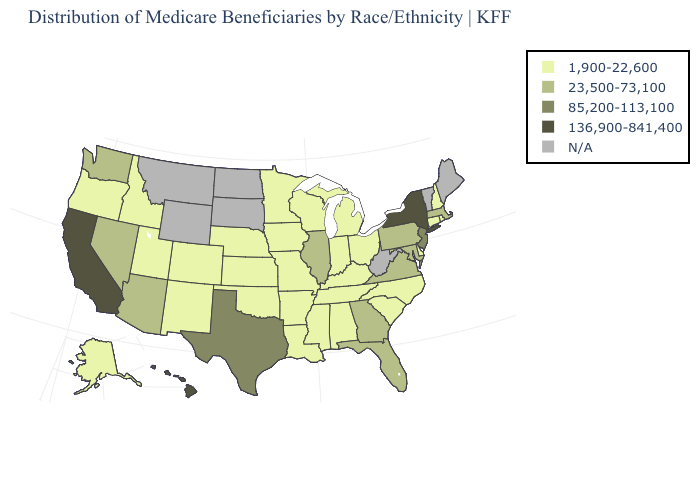Name the states that have a value in the range 23,500-73,100?
Keep it brief. Arizona, Florida, Georgia, Illinois, Maryland, Massachusetts, Nevada, Pennsylvania, Virginia, Washington. Name the states that have a value in the range N/A?
Concise answer only. Maine, Montana, North Dakota, South Dakota, Vermont, West Virginia, Wyoming. Among the states that border Nevada , which have the highest value?
Write a very short answer. California. What is the value of Florida?
Concise answer only. 23,500-73,100. Does Wisconsin have the lowest value in the USA?
Keep it brief. Yes. What is the value of Ohio?
Keep it brief. 1,900-22,600. What is the value of New Hampshire?
Quick response, please. 1,900-22,600. What is the value of New York?
Answer briefly. 136,900-841,400. Name the states that have a value in the range 85,200-113,100?
Give a very brief answer. New Jersey, Texas. What is the value of Iowa?
Be succinct. 1,900-22,600. Among the states that border Tennessee , does Kentucky have the lowest value?
Be succinct. Yes. Name the states that have a value in the range 136,900-841,400?
Short answer required. California, Hawaii, New York. What is the value of Iowa?
Quick response, please. 1,900-22,600. Which states hav the highest value in the MidWest?
Concise answer only. Illinois. 